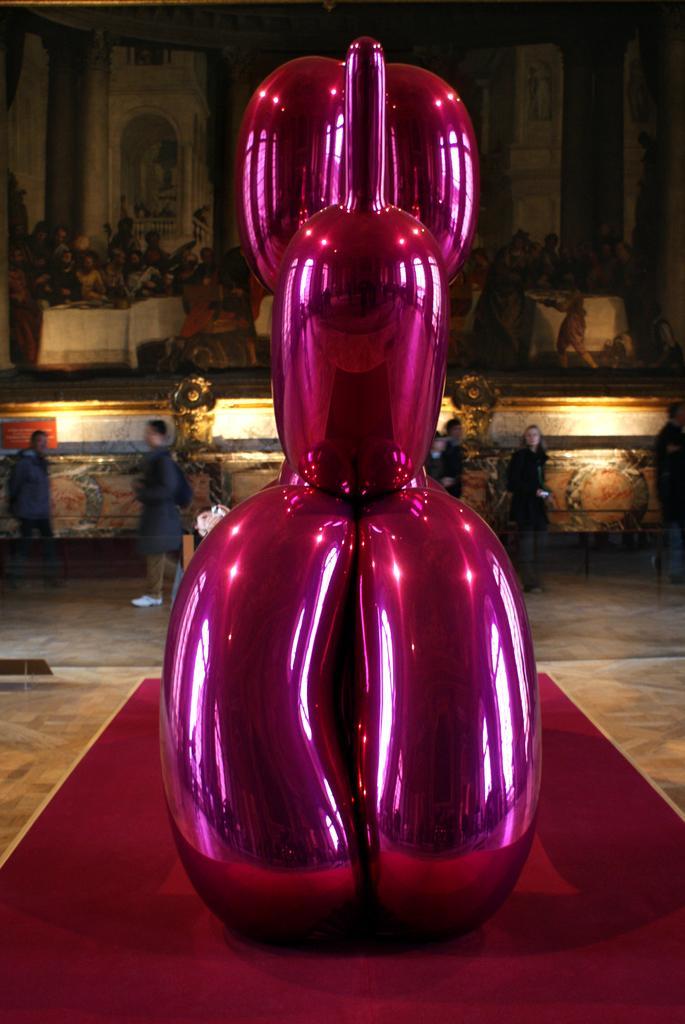Can you describe this image briefly? In the picture there is a pink sculpture and behind that there are few people, in the background there is a photo frame. 